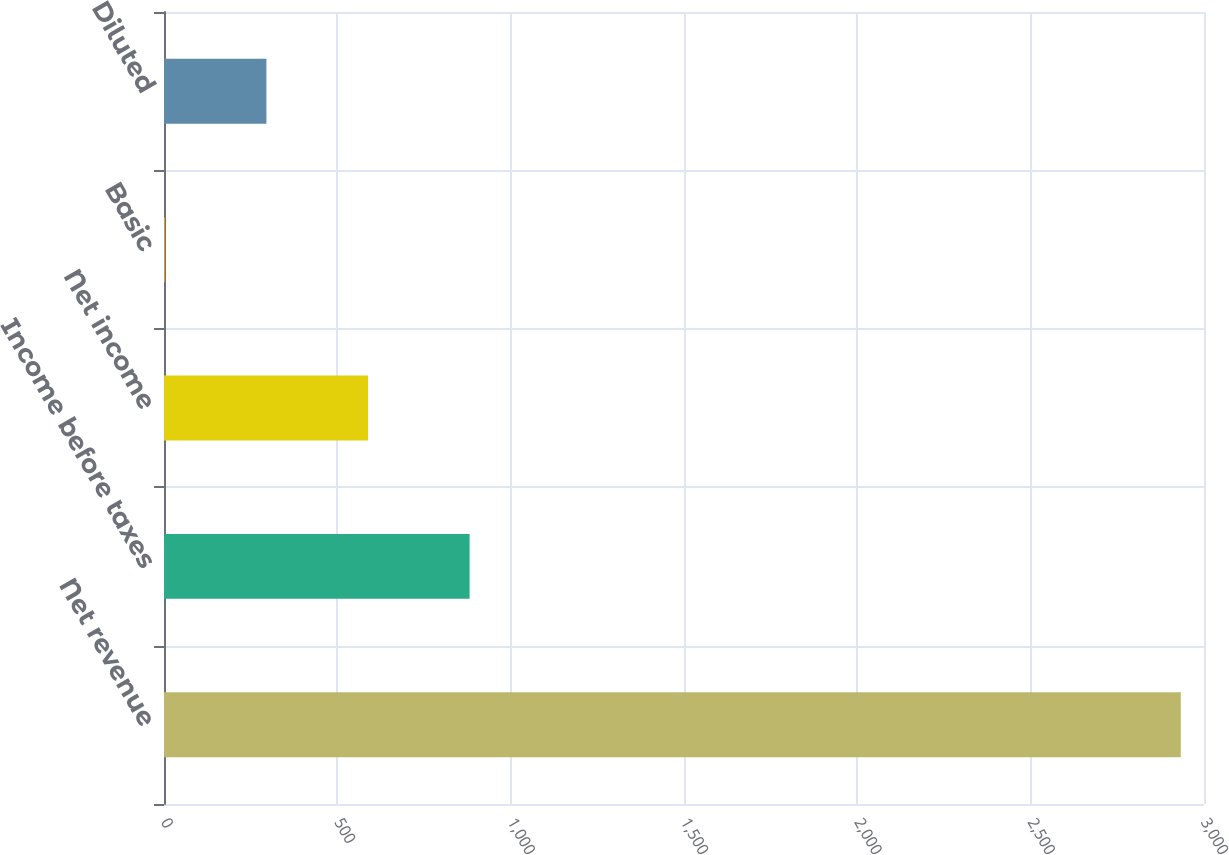Convert chart. <chart><loc_0><loc_0><loc_500><loc_500><bar_chart><fcel>Net revenue<fcel>Income before taxes<fcel>Net income<fcel>Basic<fcel>Diluted<nl><fcel>2933<fcel>881.56<fcel>588.49<fcel>2.35<fcel>295.42<nl></chart> 